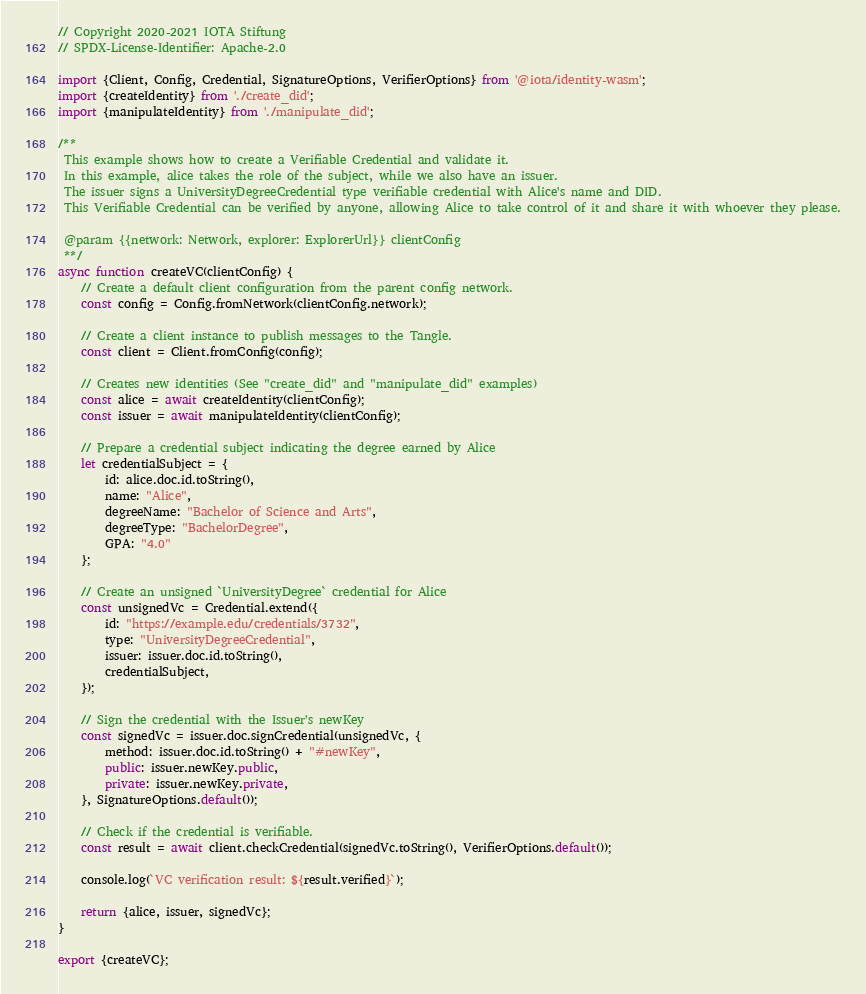Convert code to text. <code><loc_0><loc_0><loc_500><loc_500><_JavaScript_>// Copyright 2020-2021 IOTA Stiftung
// SPDX-License-Identifier: Apache-2.0

import {Client, Config, Credential, SignatureOptions, VerifierOptions} from '@iota/identity-wasm';
import {createIdentity} from './create_did';
import {manipulateIdentity} from './manipulate_did';

/**
 This example shows how to create a Verifiable Credential and validate it.
 In this example, alice takes the role of the subject, while we also have an issuer.
 The issuer signs a UniversityDegreeCredential type verifiable credential with Alice's name and DID.
 This Verifiable Credential can be verified by anyone, allowing Alice to take control of it and share it with whoever they please.

 @param {{network: Network, explorer: ExplorerUrl}} clientConfig
 **/
async function createVC(clientConfig) {
    // Create a default client configuration from the parent config network.
    const config = Config.fromNetwork(clientConfig.network);

    // Create a client instance to publish messages to the Tangle.
    const client = Client.fromConfig(config);

    // Creates new identities (See "create_did" and "manipulate_did" examples)
    const alice = await createIdentity(clientConfig);
    const issuer = await manipulateIdentity(clientConfig);

    // Prepare a credential subject indicating the degree earned by Alice
    let credentialSubject = {
        id: alice.doc.id.toString(),
        name: "Alice",
        degreeName: "Bachelor of Science and Arts",
        degreeType: "BachelorDegree",
        GPA: "4.0"
    };

    // Create an unsigned `UniversityDegree` credential for Alice
    const unsignedVc = Credential.extend({
        id: "https://example.edu/credentials/3732",
        type: "UniversityDegreeCredential",
        issuer: issuer.doc.id.toString(),
        credentialSubject,
    });

    // Sign the credential with the Issuer's newKey
    const signedVc = issuer.doc.signCredential(unsignedVc, {
        method: issuer.doc.id.toString() + "#newKey",
        public: issuer.newKey.public,
        private: issuer.newKey.private,
    }, SignatureOptions.default());

    // Check if the credential is verifiable.
    const result = await client.checkCredential(signedVc.toString(), VerifierOptions.default());

    console.log(`VC verification result: ${result.verified}`);

    return {alice, issuer, signedVc};
}

export {createVC};
</code> 